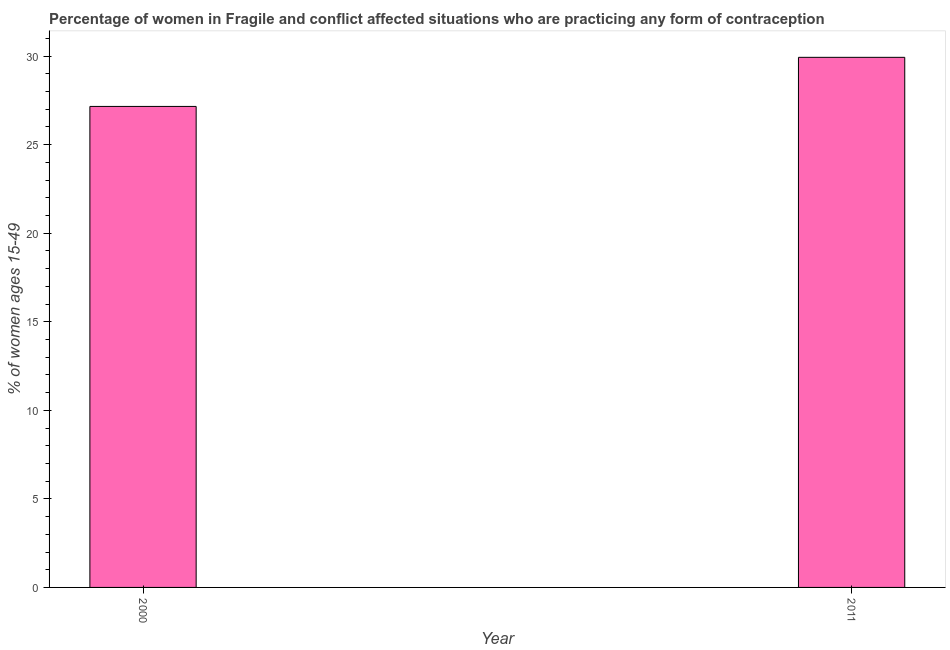Does the graph contain any zero values?
Offer a terse response. No. What is the title of the graph?
Offer a very short reply. Percentage of women in Fragile and conflict affected situations who are practicing any form of contraception. What is the label or title of the X-axis?
Your answer should be very brief. Year. What is the label or title of the Y-axis?
Offer a very short reply. % of women ages 15-49. What is the contraceptive prevalence in 2000?
Provide a short and direct response. 27.16. Across all years, what is the maximum contraceptive prevalence?
Your response must be concise. 29.93. Across all years, what is the minimum contraceptive prevalence?
Your answer should be compact. 27.16. In which year was the contraceptive prevalence minimum?
Your answer should be compact. 2000. What is the sum of the contraceptive prevalence?
Keep it short and to the point. 57.08. What is the difference between the contraceptive prevalence in 2000 and 2011?
Keep it short and to the point. -2.77. What is the average contraceptive prevalence per year?
Offer a very short reply. 28.54. What is the median contraceptive prevalence?
Your response must be concise. 28.54. Do a majority of the years between 2000 and 2011 (inclusive) have contraceptive prevalence greater than 18 %?
Give a very brief answer. Yes. What is the ratio of the contraceptive prevalence in 2000 to that in 2011?
Keep it short and to the point. 0.91. In how many years, is the contraceptive prevalence greater than the average contraceptive prevalence taken over all years?
Your answer should be compact. 1. Are all the bars in the graph horizontal?
Give a very brief answer. No. What is the difference between two consecutive major ticks on the Y-axis?
Give a very brief answer. 5. Are the values on the major ticks of Y-axis written in scientific E-notation?
Your response must be concise. No. What is the % of women ages 15-49 of 2000?
Provide a short and direct response. 27.16. What is the % of women ages 15-49 in 2011?
Offer a terse response. 29.93. What is the difference between the % of women ages 15-49 in 2000 and 2011?
Make the answer very short. -2.77. What is the ratio of the % of women ages 15-49 in 2000 to that in 2011?
Keep it short and to the point. 0.91. 